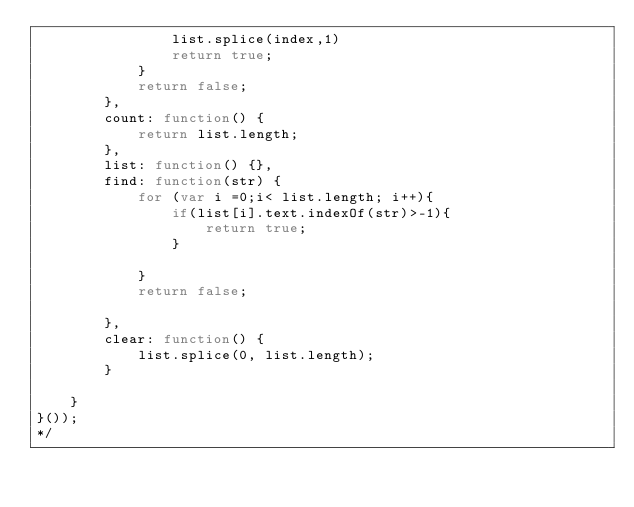Convert code to text. <code><loc_0><loc_0><loc_500><loc_500><_JavaScript_>                list.splice(index,1)
                return true;
            }
            return false;
        },
        count: function() {
            return list.length;
        },
        list: function() {},
        find: function(str) {
            for (var i =0;i< list.length; i++){
                if(list[i].text.indexOf(str)>-1){
                    return true;
                }
                
            }
            return false;
            
        },
        clear: function() {
            list.splice(0, list.length);
        }

    }
}());
*/</code> 